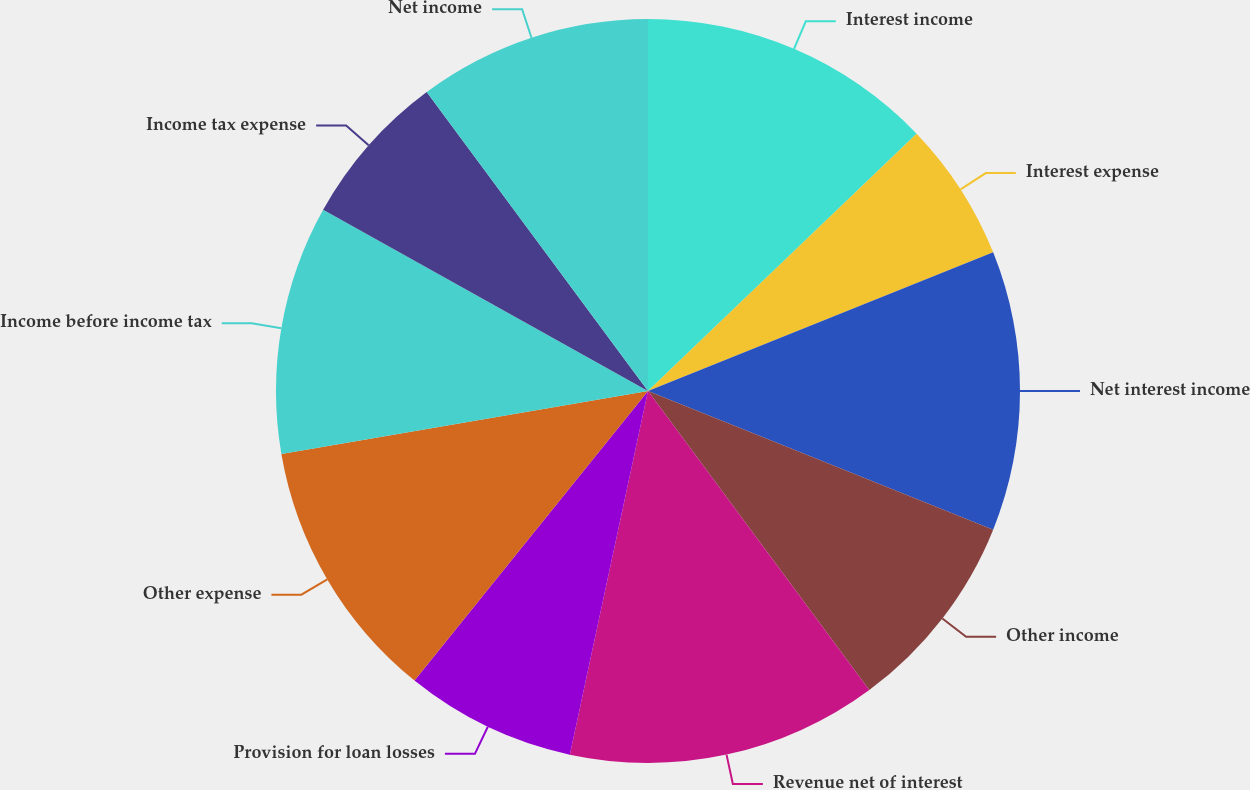Convert chart to OTSL. <chart><loc_0><loc_0><loc_500><loc_500><pie_chart><fcel>Interest income<fcel>Interest expense<fcel>Net interest income<fcel>Other income<fcel>Revenue net of interest<fcel>Provision for loan losses<fcel>Other expense<fcel>Income before income tax<fcel>Income tax expense<fcel>Net income<nl><fcel>12.84%<fcel>6.08%<fcel>12.16%<fcel>8.78%<fcel>13.51%<fcel>7.43%<fcel>11.49%<fcel>10.81%<fcel>6.76%<fcel>10.14%<nl></chart> 